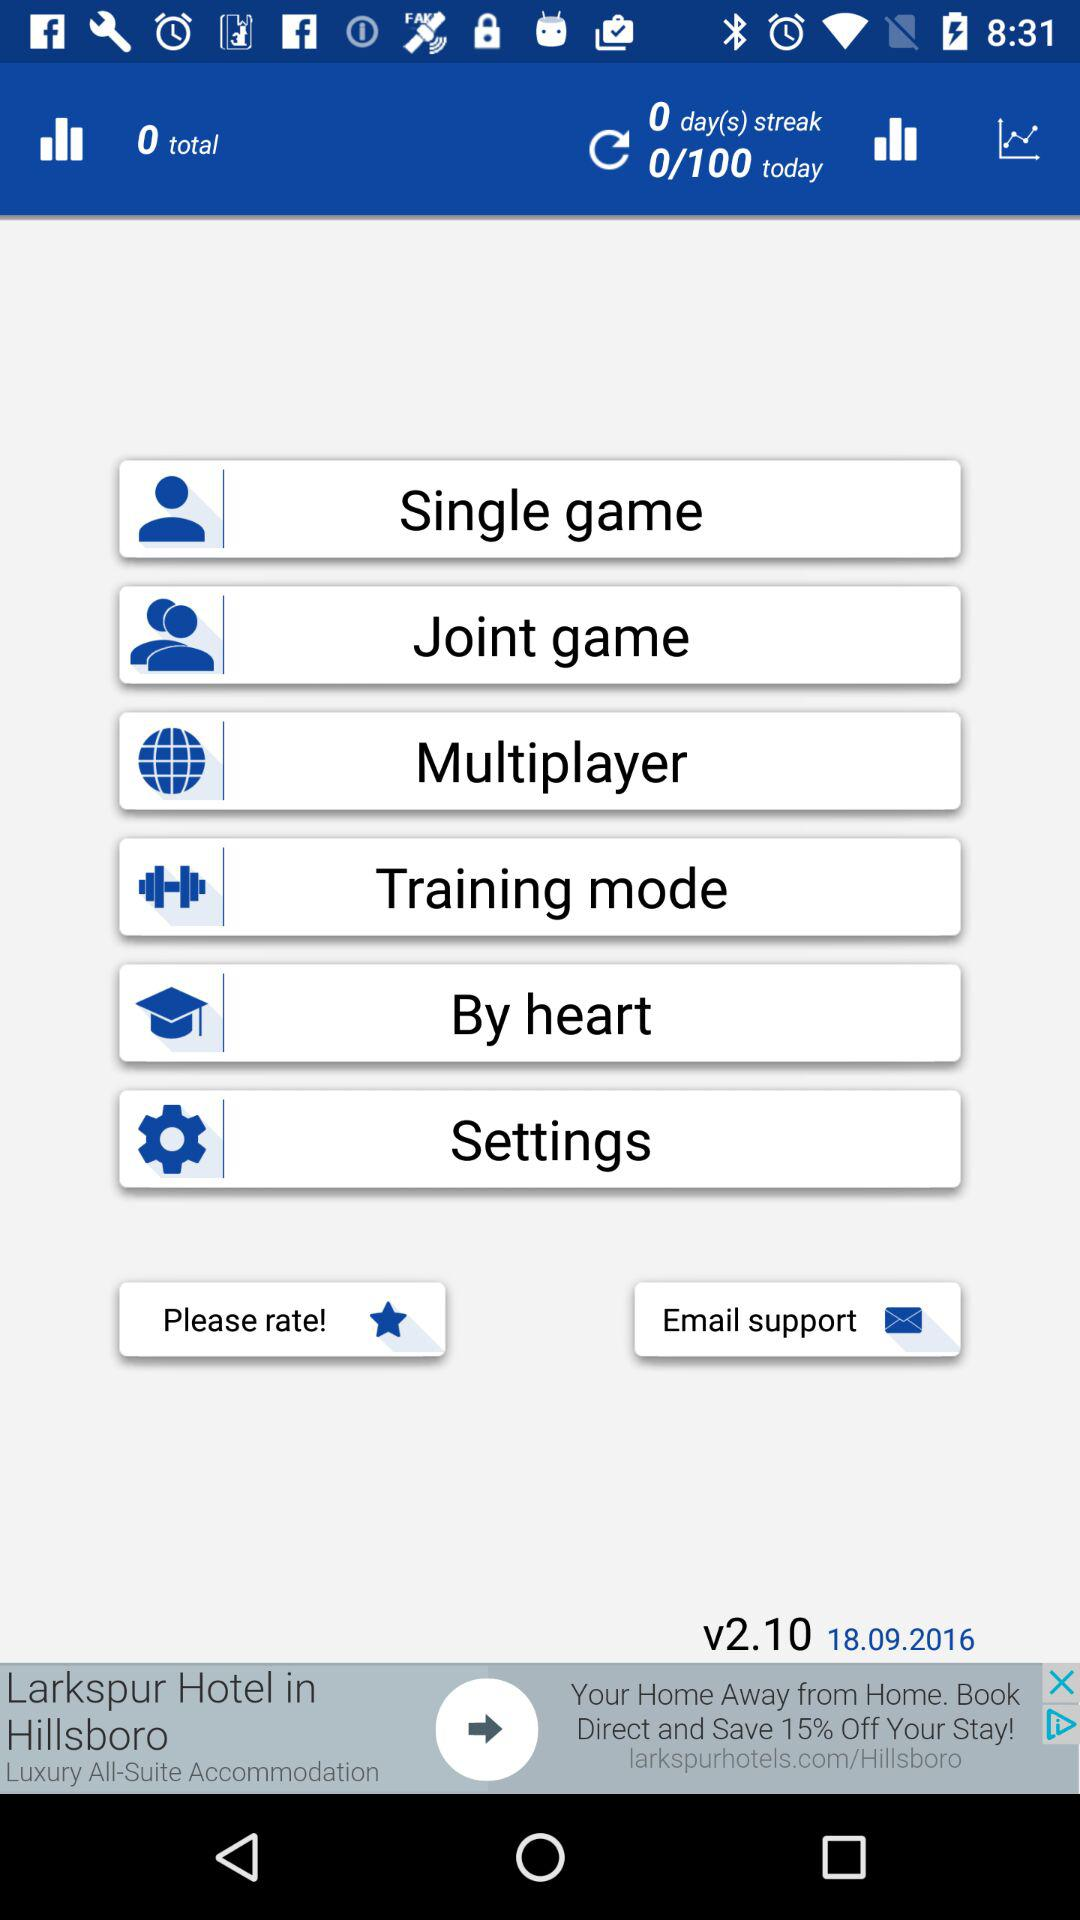What is the date? The date is 18/09/2016. 